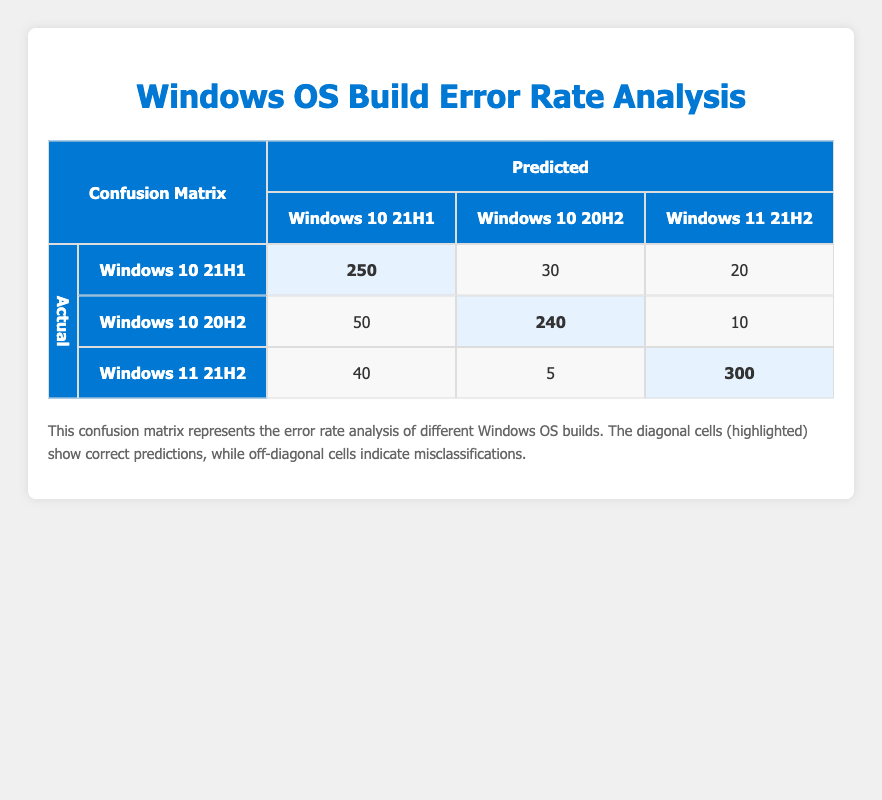What is the count of correct predictions for Windows 10 21H1? The correct predictions for Windows 10 21H1 are found in the highlighted cell of the corresponding row, which shows a count of 250.
Answer: 250 What is the total number of times Windows 10 20H2 was misclassified as Windows 10 21H1? The misclassifications are shown in the table, with Windows 10 20H2 incorrectly predicted as Windows 10 21H1 noted in the count of 50.
Answer: 50 Is there any misclassification for Windows 11 21H2? The confusion matrix shows that Windows 11 21H2 has misclassifications, specifically with counts in the cells for Windows 10 21H1 (40) and Windows 10 20H2 (5).
Answer: Yes What is the sum of all predictions for Windows 10 21H1? To find the total predictions for Windows 10 21H1, we combine the correct prediction (250) with the misclassifications (30 + 20), which totals 250 + 30 + 20 = 300.
Answer: 300 How many total predictions were made for Windows 10 20H2? The total predictions for Windows 10 20H2 include its correct prediction (240) and misclassifications (50 + 10), so adding them gives 240 + 50 + 10 = 300.
Answer: 300 What is the prediction error rate for Windows 11 21H2? The prediction error rate for Windows 11 21H2 can be calculated by looking at the misclassifications (40 + 5) compared to the correct prediction (300). The total predictions are 300 + 40 + 5 = 345; thus, the error rate is (40 + 5)/345.
Answer: Approximately 13.0% 